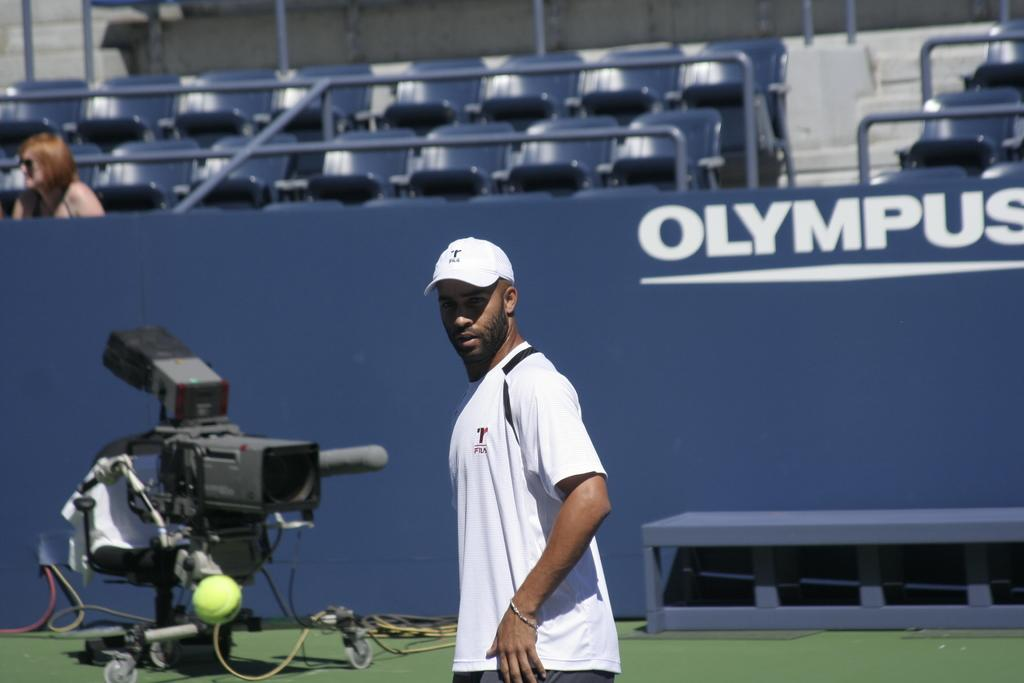<image>
Relay a brief, clear account of the picture shown. A man is standing in front of the word Olympus. 